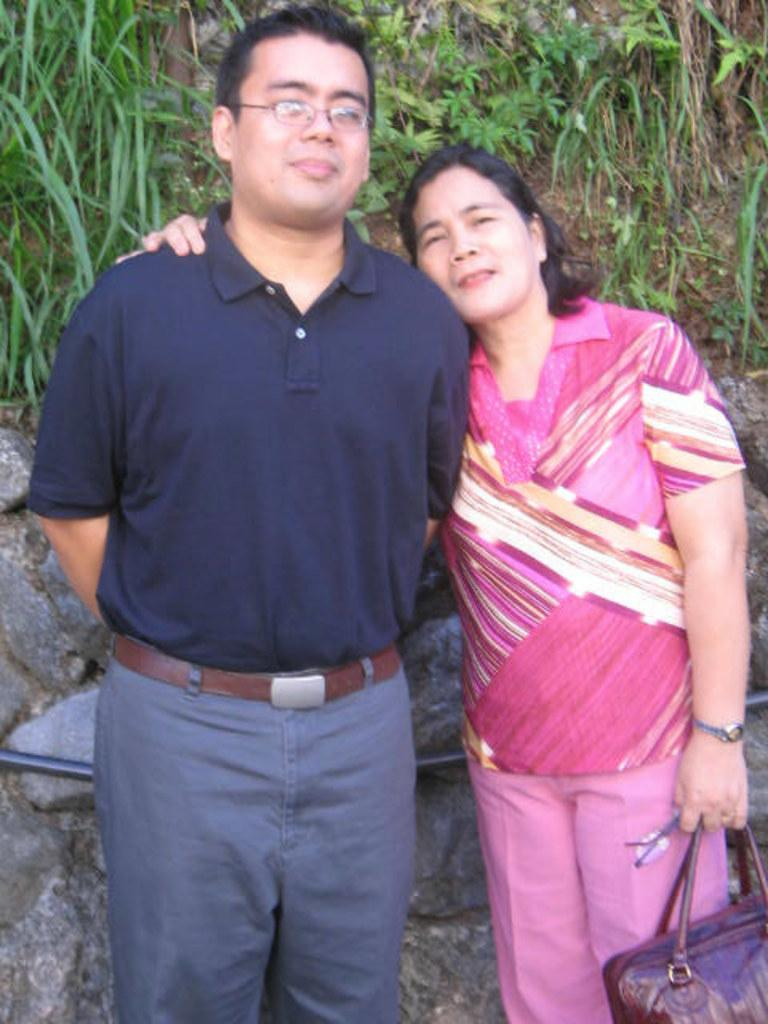How many people are in the image? There are two persons in the image. What are the two persons doing? The two persons are posing for a picture. What can be seen in the background of the image? There is grass, plants, and stones visible in the background of the image. What is the lady on the right side of the image holding? The lady on the right side of the image is holding a handbag. Can you see any water in the image? There is no water visible in the image. Is there a note being passed between the two persons in the image? There is no note present in the image. 